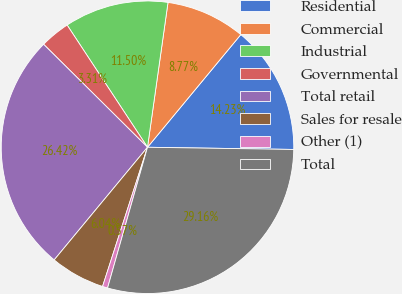<chart> <loc_0><loc_0><loc_500><loc_500><pie_chart><fcel>Residential<fcel>Commercial<fcel>Industrial<fcel>Governmental<fcel>Total retail<fcel>Sales for resale<fcel>Other (1)<fcel>Total<nl><fcel>14.23%<fcel>8.77%<fcel>11.5%<fcel>3.31%<fcel>26.42%<fcel>6.04%<fcel>0.57%<fcel>29.16%<nl></chart> 